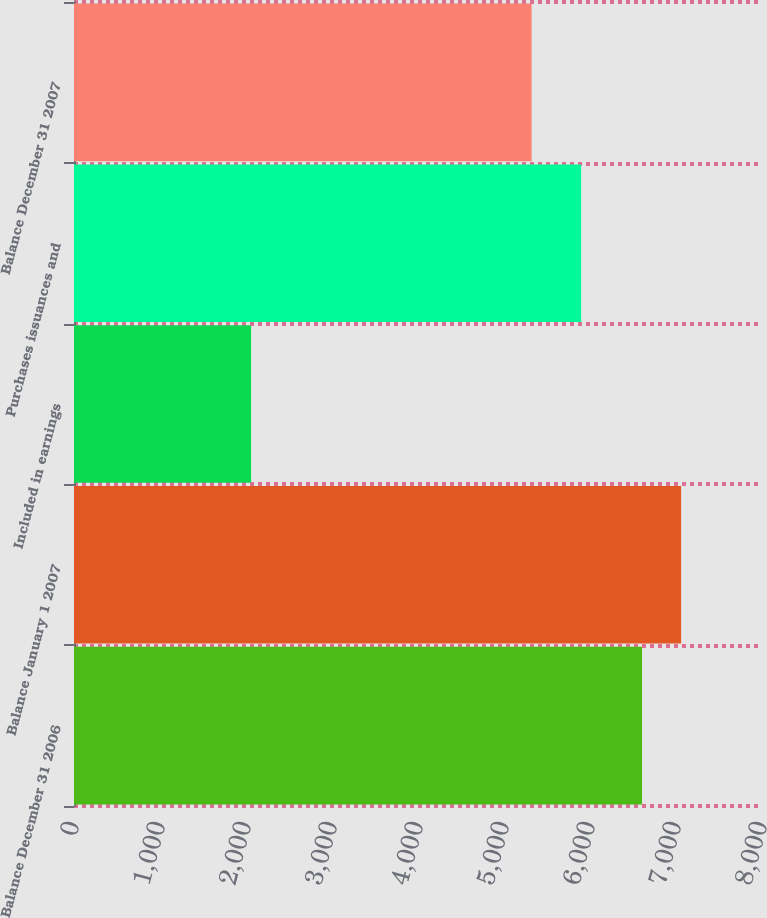<chart> <loc_0><loc_0><loc_500><loc_500><bar_chart><fcel>Balance December 31 2006<fcel>Balance January 1 2007<fcel>Included in earnings<fcel>Purchases issuances and<fcel>Balance December 31 2007<nl><fcel>6605<fcel>7059.6<fcel>2059<fcel>5897<fcel>5321<nl></chart> 